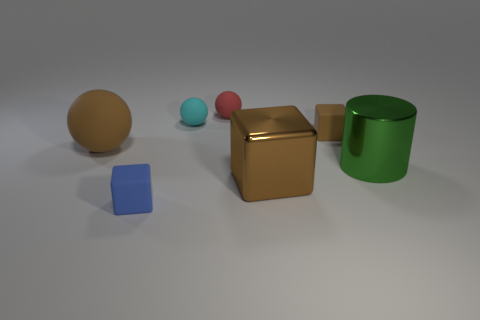The large metallic cylinder that is to the right of the matte cube behind the big metallic object that is behind the big metal block is what color?
Provide a succinct answer. Green. Do the metal thing that is in front of the big green shiny cylinder and the brown rubber thing that is to the right of the tiny cyan object have the same shape?
Your answer should be very brief. Yes. How many big brown things are there?
Offer a very short reply. 2. There is a rubber ball that is the same size as the red object; what color is it?
Provide a succinct answer. Cyan. Is the tiny cube that is to the left of the cyan thing made of the same material as the big object that is in front of the green shiny cylinder?
Your answer should be compact. No. There is a rubber sphere that is to the left of the block to the left of the big brown metal thing; how big is it?
Give a very brief answer. Large. What material is the brown block that is in front of the green shiny cylinder?
Your answer should be very brief. Metal. How many things are matte spheres that are right of the blue cube or brown rubber things right of the red ball?
Give a very brief answer. 3. What is the material of the big brown object that is the same shape as the blue thing?
Make the answer very short. Metal. There is a thing on the left side of the blue cube; is it the same color as the small rubber cube behind the large sphere?
Your answer should be compact. Yes. 